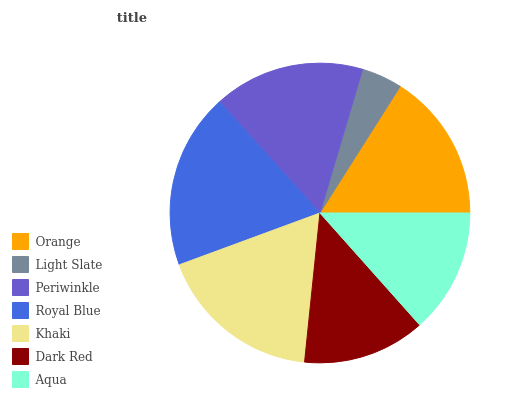Is Light Slate the minimum?
Answer yes or no. Yes. Is Royal Blue the maximum?
Answer yes or no. Yes. Is Periwinkle the minimum?
Answer yes or no. No. Is Periwinkle the maximum?
Answer yes or no. No. Is Periwinkle greater than Light Slate?
Answer yes or no. Yes. Is Light Slate less than Periwinkle?
Answer yes or no. Yes. Is Light Slate greater than Periwinkle?
Answer yes or no. No. Is Periwinkle less than Light Slate?
Answer yes or no. No. Is Orange the high median?
Answer yes or no. Yes. Is Orange the low median?
Answer yes or no. Yes. Is Aqua the high median?
Answer yes or no. No. Is Dark Red the low median?
Answer yes or no. No. 